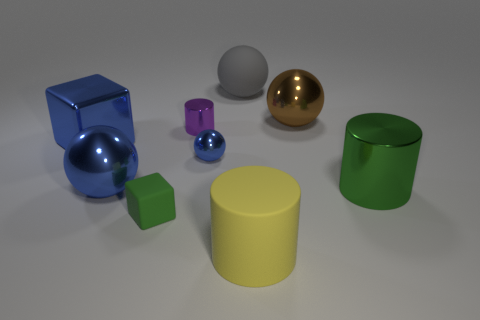How do the sizes of the blue and green objects compare to each other? The blue cube is smaller and has a more compact shape compared to the larger, wider green cylinder. 